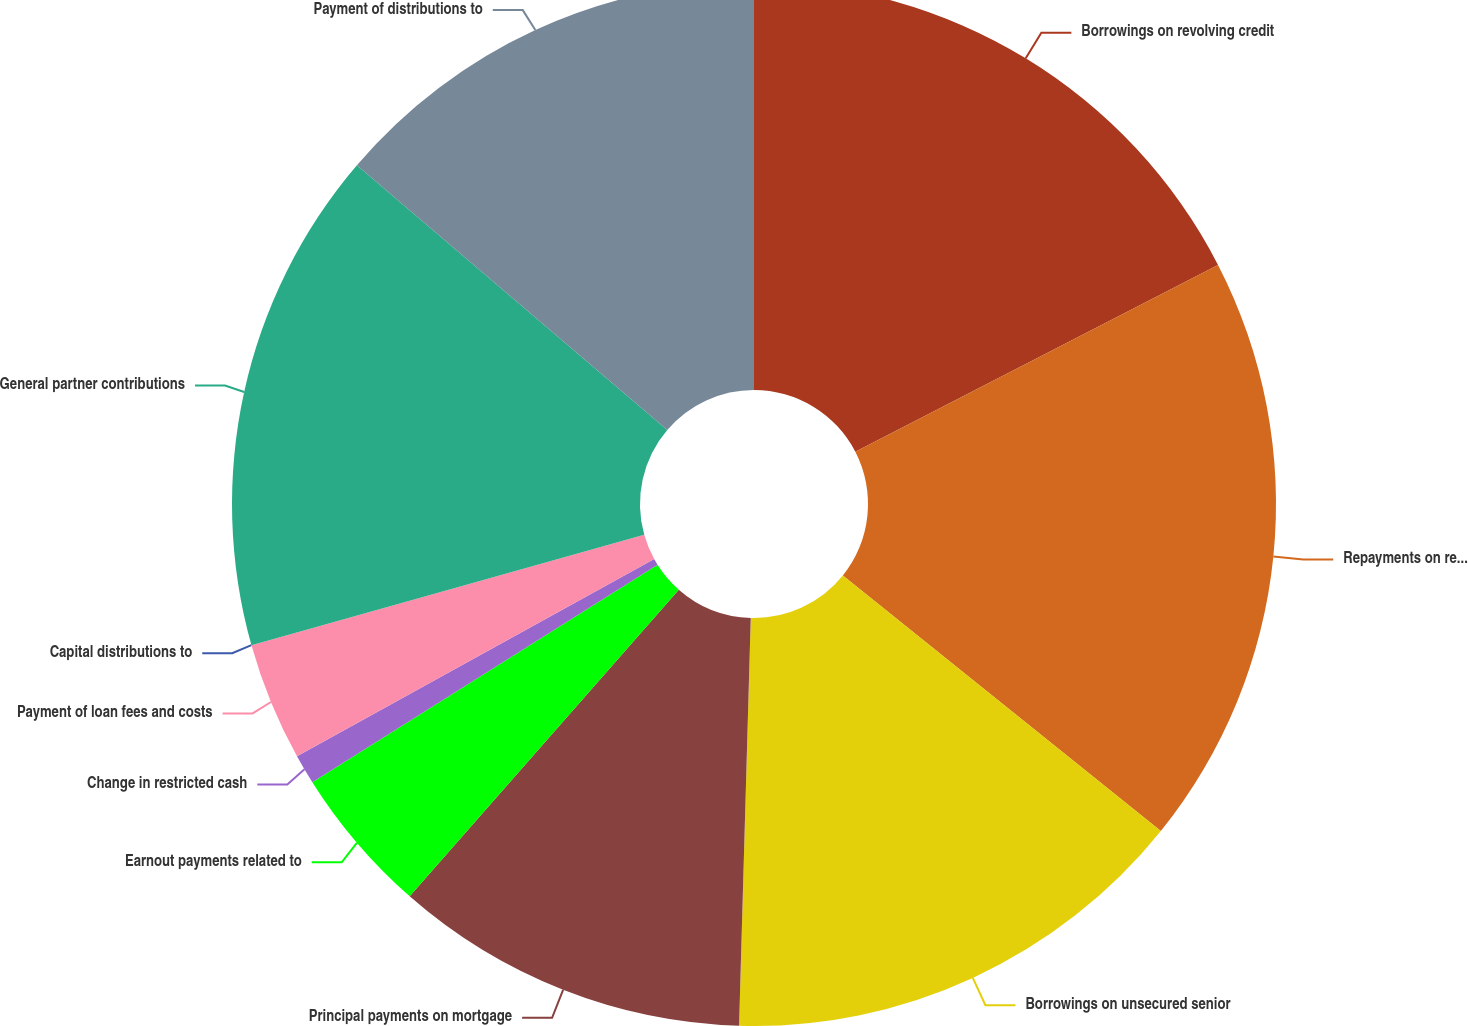<chart> <loc_0><loc_0><loc_500><loc_500><pie_chart><fcel>Borrowings on revolving credit<fcel>Repayments on revolving credit<fcel>Borrowings on unsecured senior<fcel>Principal payments on mortgage<fcel>Earnout payments related to<fcel>Change in restricted cash<fcel>Payment of loan fees and costs<fcel>Capital distributions to<fcel>General partner contributions<fcel>Payment of distributions to<nl><fcel>17.43%<fcel>18.35%<fcel>14.68%<fcel>11.01%<fcel>4.59%<fcel>0.92%<fcel>3.67%<fcel>0.0%<fcel>15.6%<fcel>13.76%<nl></chart> 